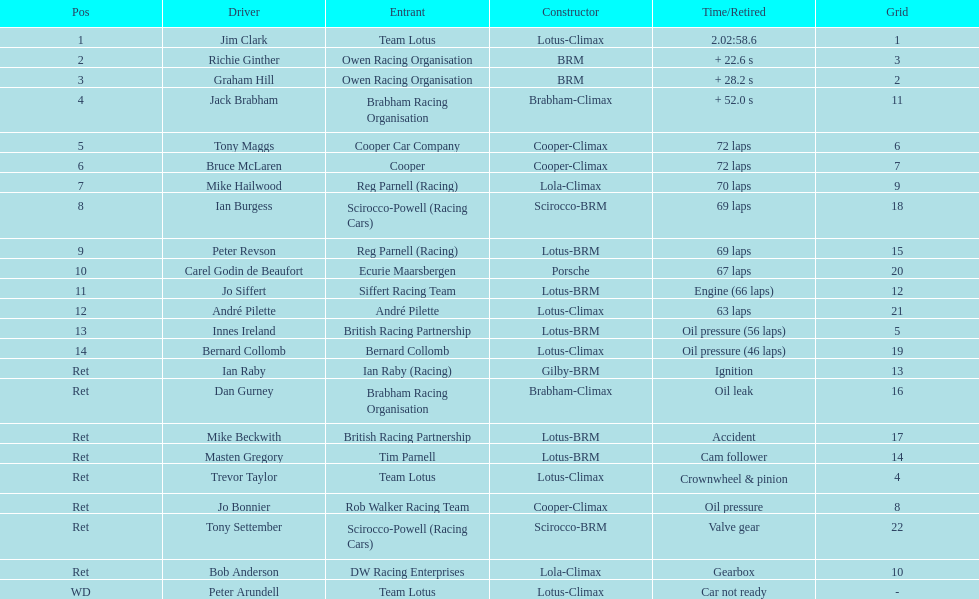What was the same problem that bernard collomb had as innes ireland? Oil pressure. 